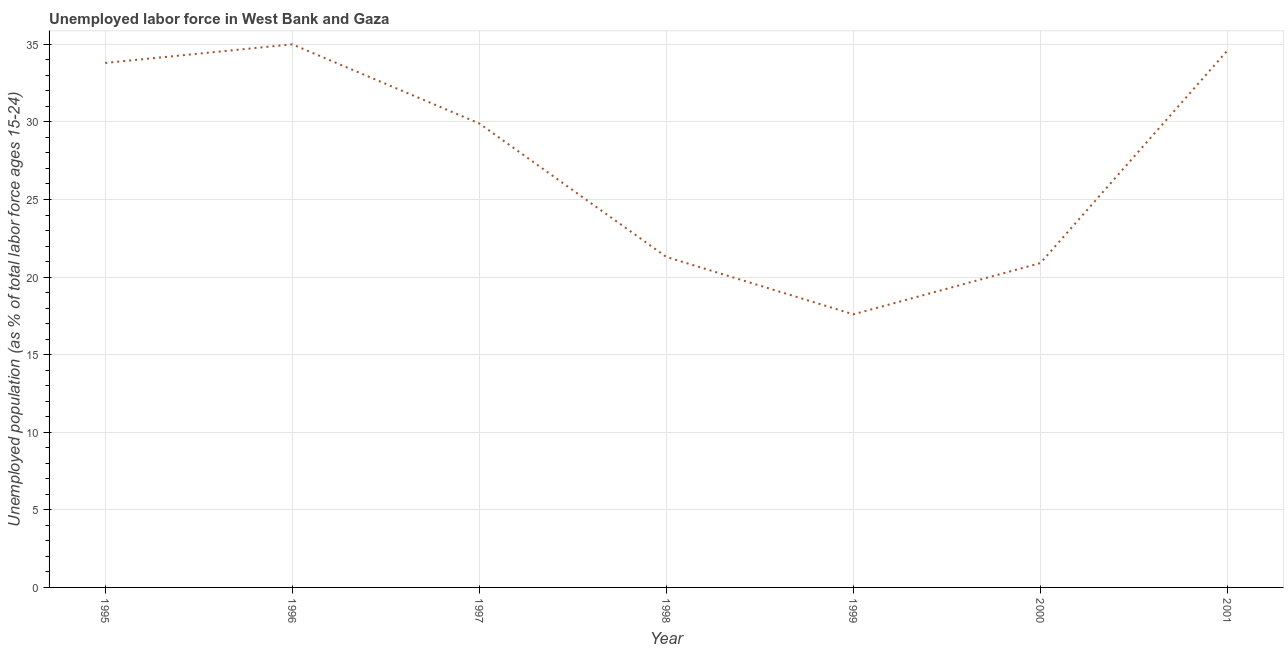What is the total unemployed youth population in 1999?
Ensure brevity in your answer.  17.6. Across all years, what is the minimum total unemployed youth population?
Keep it short and to the point. 17.6. In which year was the total unemployed youth population maximum?
Ensure brevity in your answer.  1996. What is the sum of the total unemployed youth population?
Give a very brief answer. 193.1. What is the difference between the total unemployed youth population in 1995 and 2001?
Provide a succinct answer. -0.8. What is the average total unemployed youth population per year?
Your answer should be compact. 27.59. What is the median total unemployed youth population?
Keep it short and to the point. 29.9. What is the ratio of the total unemployed youth population in 1995 to that in 1999?
Ensure brevity in your answer.  1.92. Is the total unemployed youth population in 2000 less than that in 2001?
Your answer should be compact. Yes. What is the difference between the highest and the second highest total unemployed youth population?
Your answer should be very brief. 0.4. Is the sum of the total unemployed youth population in 1995 and 1997 greater than the maximum total unemployed youth population across all years?
Your response must be concise. Yes. What is the difference between the highest and the lowest total unemployed youth population?
Your response must be concise. 17.4. How many lines are there?
Give a very brief answer. 1. How many years are there in the graph?
Offer a very short reply. 7. What is the difference between two consecutive major ticks on the Y-axis?
Make the answer very short. 5. Does the graph contain grids?
Offer a very short reply. Yes. What is the title of the graph?
Your answer should be compact. Unemployed labor force in West Bank and Gaza. What is the label or title of the X-axis?
Keep it short and to the point. Year. What is the label or title of the Y-axis?
Give a very brief answer. Unemployed population (as % of total labor force ages 15-24). What is the Unemployed population (as % of total labor force ages 15-24) in 1995?
Keep it short and to the point. 33.8. What is the Unemployed population (as % of total labor force ages 15-24) of 1996?
Your response must be concise. 35. What is the Unemployed population (as % of total labor force ages 15-24) of 1997?
Make the answer very short. 29.9. What is the Unemployed population (as % of total labor force ages 15-24) in 1998?
Give a very brief answer. 21.3. What is the Unemployed population (as % of total labor force ages 15-24) of 1999?
Your response must be concise. 17.6. What is the Unemployed population (as % of total labor force ages 15-24) in 2000?
Offer a terse response. 20.9. What is the Unemployed population (as % of total labor force ages 15-24) of 2001?
Offer a very short reply. 34.6. What is the difference between the Unemployed population (as % of total labor force ages 15-24) in 1995 and 1996?
Give a very brief answer. -1.2. What is the difference between the Unemployed population (as % of total labor force ages 15-24) in 1995 and 1997?
Offer a terse response. 3.9. What is the difference between the Unemployed population (as % of total labor force ages 15-24) in 1995 and 1998?
Your answer should be very brief. 12.5. What is the difference between the Unemployed population (as % of total labor force ages 15-24) in 1995 and 1999?
Make the answer very short. 16.2. What is the difference between the Unemployed population (as % of total labor force ages 15-24) in 1995 and 2000?
Offer a very short reply. 12.9. What is the difference between the Unemployed population (as % of total labor force ages 15-24) in 1995 and 2001?
Your answer should be compact. -0.8. What is the difference between the Unemployed population (as % of total labor force ages 15-24) in 1996 and 1997?
Offer a terse response. 5.1. What is the difference between the Unemployed population (as % of total labor force ages 15-24) in 1996 and 1998?
Keep it short and to the point. 13.7. What is the difference between the Unemployed population (as % of total labor force ages 15-24) in 1996 and 1999?
Offer a terse response. 17.4. What is the difference between the Unemployed population (as % of total labor force ages 15-24) in 1996 and 2001?
Keep it short and to the point. 0.4. What is the difference between the Unemployed population (as % of total labor force ages 15-24) in 1997 and 2000?
Give a very brief answer. 9. What is the difference between the Unemployed population (as % of total labor force ages 15-24) in 1998 and 2000?
Give a very brief answer. 0.4. What is the difference between the Unemployed population (as % of total labor force ages 15-24) in 1998 and 2001?
Offer a terse response. -13.3. What is the difference between the Unemployed population (as % of total labor force ages 15-24) in 1999 and 2001?
Provide a succinct answer. -17. What is the difference between the Unemployed population (as % of total labor force ages 15-24) in 2000 and 2001?
Give a very brief answer. -13.7. What is the ratio of the Unemployed population (as % of total labor force ages 15-24) in 1995 to that in 1997?
Provide a succinct answer. 1.13. What is the ratio of the Unemployed population (as % of total labor force ages 15-24) in 1995 to that in 1998?
Your response must be concise. 1.59. What is the ratio of the Unemployed population (as % of total labor force ages 15-24) in 1995 to that in 1999?
Make the answer very short. 1.92. What is the ratio of the Unemployed population (as % of total labor force ages 15-24) in 1995 to that in 2000?
Keep it short and to the point. 1.62. What is the ratio of the Unemployed population (as % of total labor force ages 15-24) in 1995 to that in 2001?
Provide a short and direct response. 0.98. What is the ratio of the Unemployed population (as % of total labor force ages 15-24) in 1996 to that in 1997?
Your answer should be very brief. 1.17. What is the ratio of the Unemployed population (as % of total labor force ages 15-24) in 1996 to that in 1998?
Give a very brief answer. 1.64. What is the ratio of the Unemployed population (as % of total labor force ages 15-24) in 1996 to that in 1999?
Your response must be concise. 1.99. What is the ratio of the Unemployed population (as % of total labor force ages 15-24) in 1996 to that in 2000?
Provide a short and direct response. 1.68. What is the ratio of the Unemployed population (as % of total labor force ages 15-24) in 1996 to that in 2001?
Your answer should be compact. 1.01. What is the ratio of the Unemployed population (as % of total labor force ages 15-24) in 1997 to that in 1998?
Your answer should be very brief. 1.4. What is the ratio of the Unemployed population (as % of total labor force ages 15-24) in 1997 to that in 1999?
Your answer should be very brief. 1.7. What is the ratio of the Unemployed population (as % of total labor force ages 15-24) in 1997 to that in 2000?
Your answer should be very brief. 1.43. What is the ratio of the Unemployed population (as % of total labor force ages 15-24) in 1997 to that in 2001?
Ensure brevity in your answer.  0.86. What is the ratio of the Unemployed population (as % of total labor force ages 15-24) in 1998 to that in 1999?
Give a very brief answer. 1.21. What is the ratio of the Unemployed population (as % of total labor force ages 15-24) in 1998 to that in 2000?
Offer a terse response. 1.02. What is the ratio of the Unemployed population (as % of total labor force ages 15-24) in 1998 to that in 2001?
Give a very brief answer. 0.62. What is the ratio of the Unemployed population (as % of total labor force ages 15-24) in 1999 to that in 2000?
Your response must be concise. 0.84. What is the ratio of the Unemployed population (as % of total labor force ages 15-24) in 1999 to that in 2001?
Your response must be concise. 0.51. What is the ratio of the Unemployed population (as % of total labor force ages 15-24) in 2000 to that in 2001?
Give a very brief answer. 0.6. 